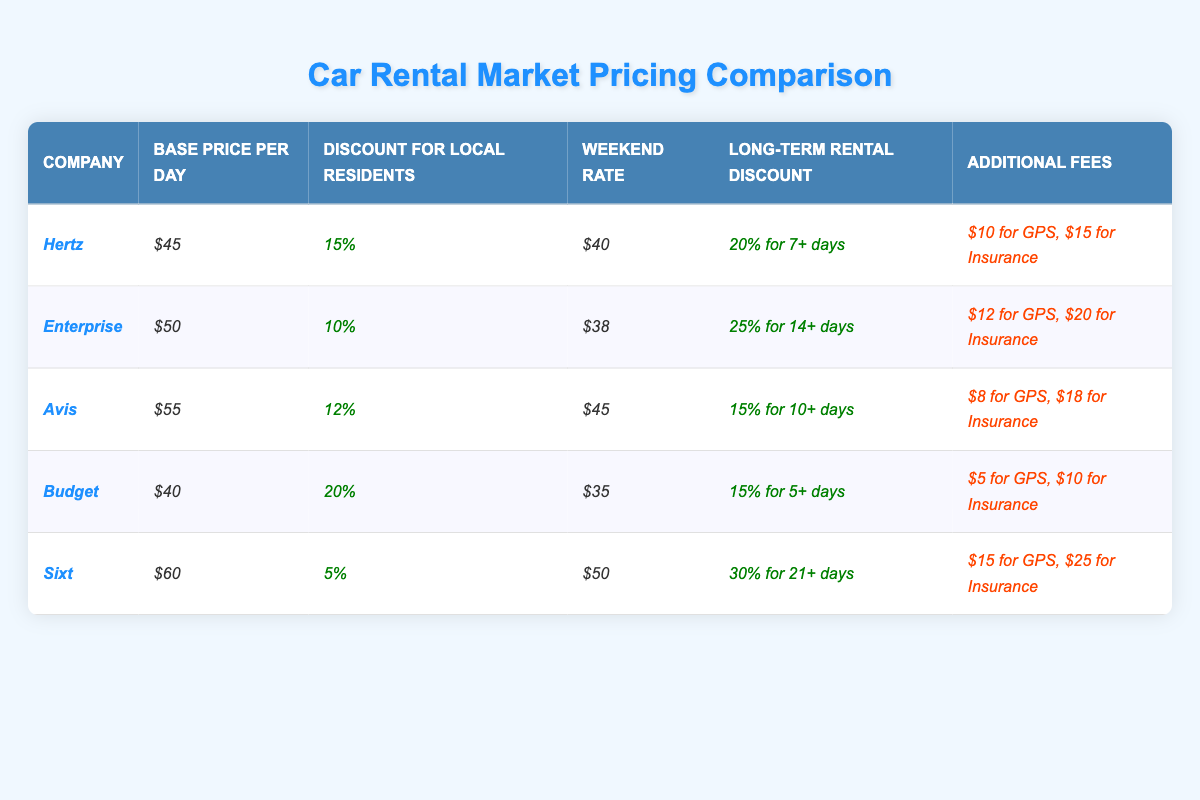What is the base price per day for Budget? The table shows the "Base Price per Day" for Budget is listed as $40.
Answer: $40 Which company offers the highest discount for local residents? The discounts for local residents are 15% for Hertz, 10% for Enterprise, 12% for Avis, 20% for Budget, and 5% for Sixt. Budget offers the highest discount of 20%.
Answer: Budget What is the weekend rate for Enterprise? According to the table, the "Weekend Rate" for Enterprise is $38.
Answer: $38 If a customer rents a car from Hertz for a week, what would the total cost be before additional fees? The base price per day for Hertz is $45. For 7 days, the cost would be $45 x 7 = $315.
Answer: $315 What is the total cost for a weekend rental from Budget, including additional fees for GPS and insurance? Budget's weekend rate is $35. With an additional GPS fee of $5 and insurance fee of $10, the total cost would be $35 + $5 + $10 = $50.
Answer: $50 Does Avis offer a lower base price per day than Enterprise? Avis has a base price of $55, while Enterprise has a base price of $50. Thus, Avis does not offer a lower price.
Answer: No If a customer rents from Sixt for 21 days, what percentage discount do they receive? Sixt offers a 30% discount for rentals of 21 days or more.
Answer: 30% Calculate the average base price per day across all companies listed in the table. The base prices are $45, $50, $55, $40, and $60. The sum is $250, divided by 5 gives an average of $50.
Answer: $50 What are the additional fees for GPS and insurance with Avis? The table indicates that Avis charges $8 for GPS and $18 for insurance.
Answer: $8 for GPS, $18 for insurance Which company has the longest long-term rental discount condition? Comparing the long-term rental discounts, Sixt offers 30% but requires 21+ days, which is longer than the other companies' requirements.
Answer: Sixt 